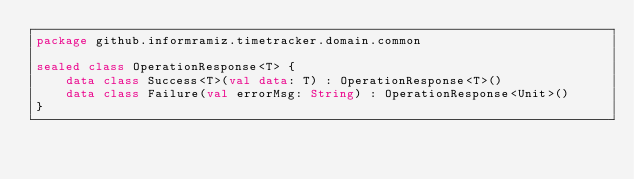<code> <loc_0><loc_0><loc_500><loc_500><_Kotlin_>package github.informramiz.timetracker.domain.common

sealed class OperationResponse<T> {
    data class Success<T>(val data: T) : OperationResponse<T>()
    data class Failure(val errorMsg: String) : OperationResponse<Unit>()
}
</code> 